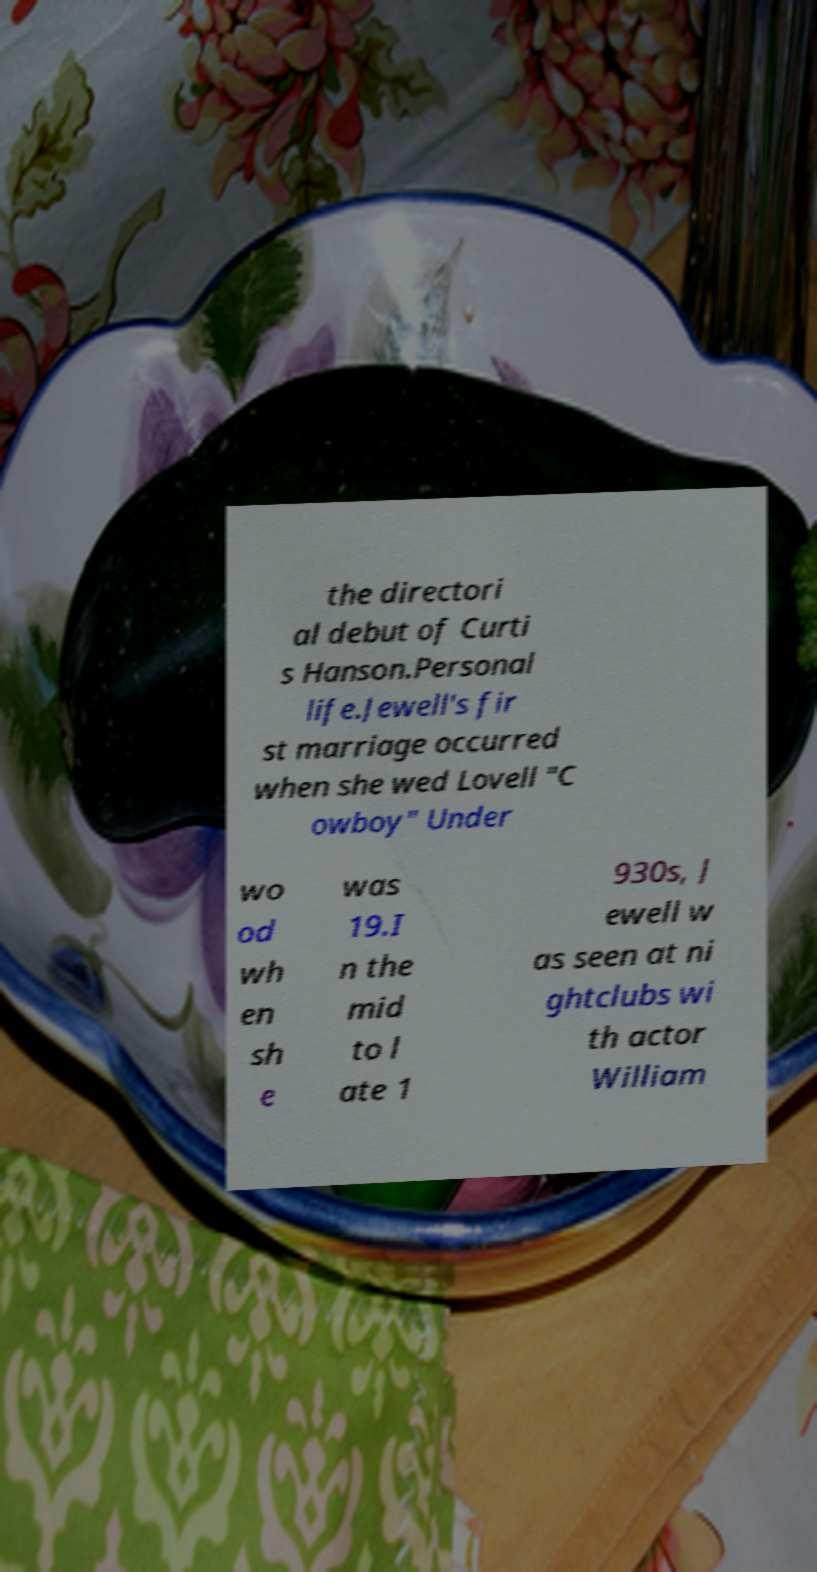Can you accurately transcribe the text from the provided image for me? the directori al debut of Curti s Hanson.Personal life.Jewell's fir st marriage occurred when she wed Lovell "C owboy" Under wo od wh en sh e was 19.I n the mid to l ate 1 930s, J ewell w as seen at ni ghtclubs wi th actor William 